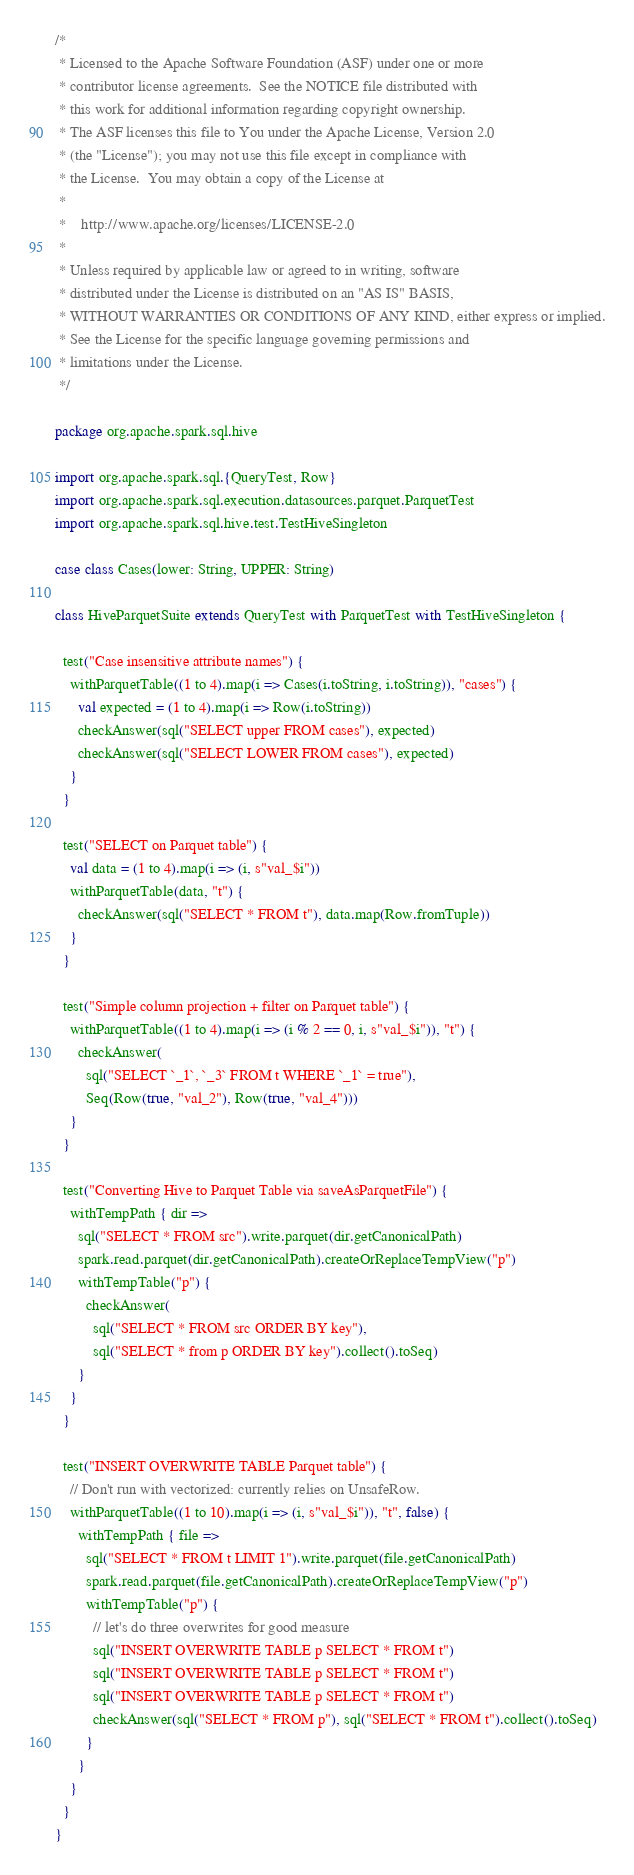<code> <loc_0><loc_0><loc_500><loc_500><_Scala_>/*
 * Licensed to the Apache Software Foundation (ASF) under one or more
 * contributor license agreements.  See the NOTICE file distributed with
 * this work for additional information regarding copyright ownership.
 * The ASF licenses this file to You under the Apache License, Version 2.0
 * (the "License"); you may not use this file except in compliance with
 * the License.  You may obtain a copy of the License at
 *
 *    http://www.apache.org/licenses/LICENSE-2.0
 *
 * Unless required by applicable law or agreed to in writing, software
 * distributed under the License is distributed on an "AS IS" BASIS,
 * WITHOUT WARRANTIES OR CONDITIONS OF ANY KIND, either express or implied.
 * See the License for the specific language governing permissions and
 * limitations under the License.
 */

package org.apache.spark.sql.hive

import org.apache.spark.sql.{QueryTest, Row}
import org.apache.spark.sql.execution.datasources.parquet.ParquetTest
import org.apache.spark.sql.hive.test.TestHiveSingleton

case class Cases(lower: String, UPPER: String)

class HiveParquetSuite extends QueryTest with ParquetTest with TestHiveSingleton {

  test("Case insensitive attribute names") {
    withParquetTable((1 to 4).map(i => Cases(i.toString, i.toString)), "cases") {
      val expected = (1 to 4).map(i => Row(i.toString))
      checkAnswer(sql("SELECT upper FROM cases"), expected)
      checkAnswer(sql("SELECT LOWER FROM cases"), expected)
    }
  }

  test("SELECT on Parquet table") {
    val data = (1 to 4).map(i => (i, s"val_$i"))
    withParquetTable(data, "t") {
      checkAnswer(sql("SELECT * FROM t"), data.map(Row.fromTuple))
    }
  }

  test("Simple column projection + filter on Parquet table") {
    withParquetTable((1 to 4).map(i => (i % 2 == 0, i, s"val_$i")), "t") {
      checkAnswer(
        sql("SELECT `_1`, `_3` FROM t WHERE `_1` = true"),
        Seq(Row(true, "val_2"), Row(true, "val_4")))
    }
  }

  test("Converting Hive to Parquet Table via saveAsParquetFile") {
    withTempPath { dir =>
      sql("SELECT * FROM src").write.parquet(dir.getCanonicalPath)
      spark.read.parquet(dir.getCanonicalPath).createOrReplaceTempView("p")
      withTempTable("p") {
        checkAnswer(
          sql("SELECT * FROM src ORDER BY key"),
          sql("SELECT * from p ORDER BY key").collect().toSeq)
      }
    }
  }

  test("INSERT OVERWRITE TABLE Parquet table") {
    // Don't run with vectorized: currently relies on UnsafeRow.
    withParquetTable((1 to 10).map(i => (i, s"val_$i")), "t", false) {
      withTempPath { file =>
        sql("SELECT * FROM t LIMIT 1").write.parquet(file.getCanonicalPath)
        spark.read.parquet(file.getCanonicalPath).createOrReplaceTempView("p")
        withTempTable("p") {
          // let's do three overwrites for good measure
          sql("INSERT OVERWRITE TABLE p SELECT * FROM t")
          sql("INSERT OVERWRITE TABLE p SELECT * FROM t")
          sql("INSERT OVERWRITE TABLE p SELECT * FROM t")
          checkAnswer(sql("SELECT * FROM p"), sql("SELECT * FROM t").collect().toSeq)
        }
      }
    }
  }
}
</code> 